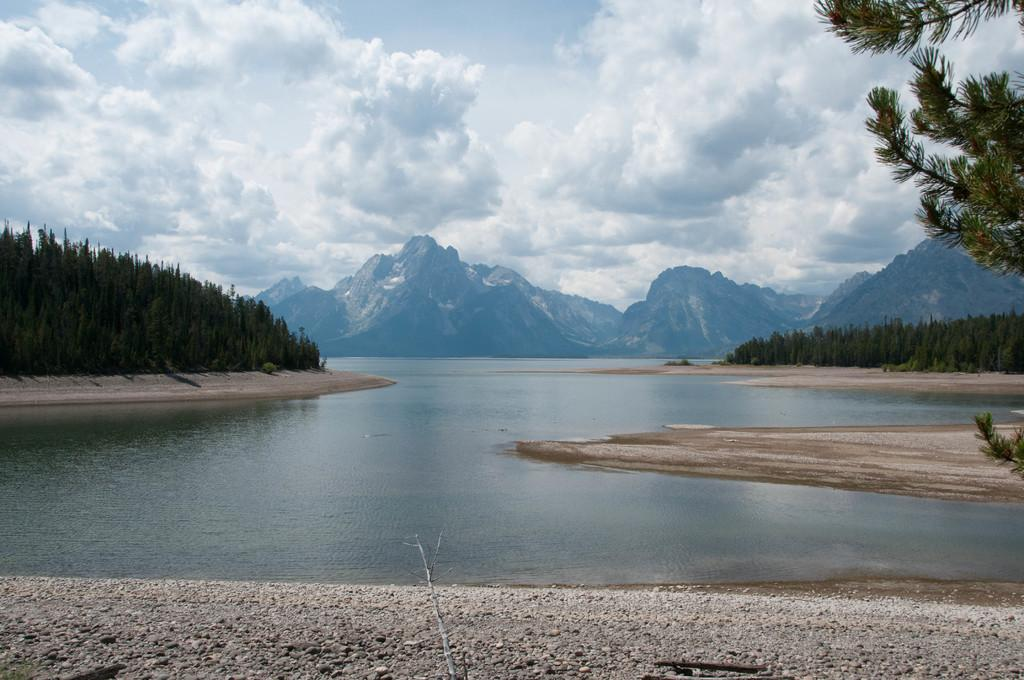What is visible in the image? Water, trees, and hills are visible in the image. Can you describe the sky in the image? The sky is cloudy in the image. What type of landscape is depicted in the image? The image features a landscape with water, trees, and hills. Where is the calendar located in the image? There is no calendar present in the image. What type of wood can be seen in the image? There is no wood visible in the image. 